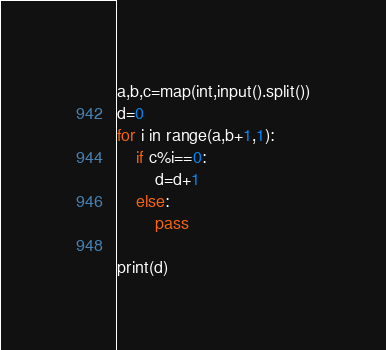<code> <loc_0><loc_0><loc_500><loc_500><_Python_>a,b,c=map(int,input().split())
d=0
for i in range(a,b+1,1):
    if c%i==0:
        d=d+1
    else:
        pass

print(d)
</code> 